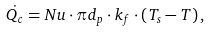<formula> <loc_0><loc_0><loc_500><loc_500>\dot { Q _ { c } } = N u \cdot \pi d _ { p } \cdot k _ { f } \cdot \left ( T _ { s } - T \right ) ,</formula> 